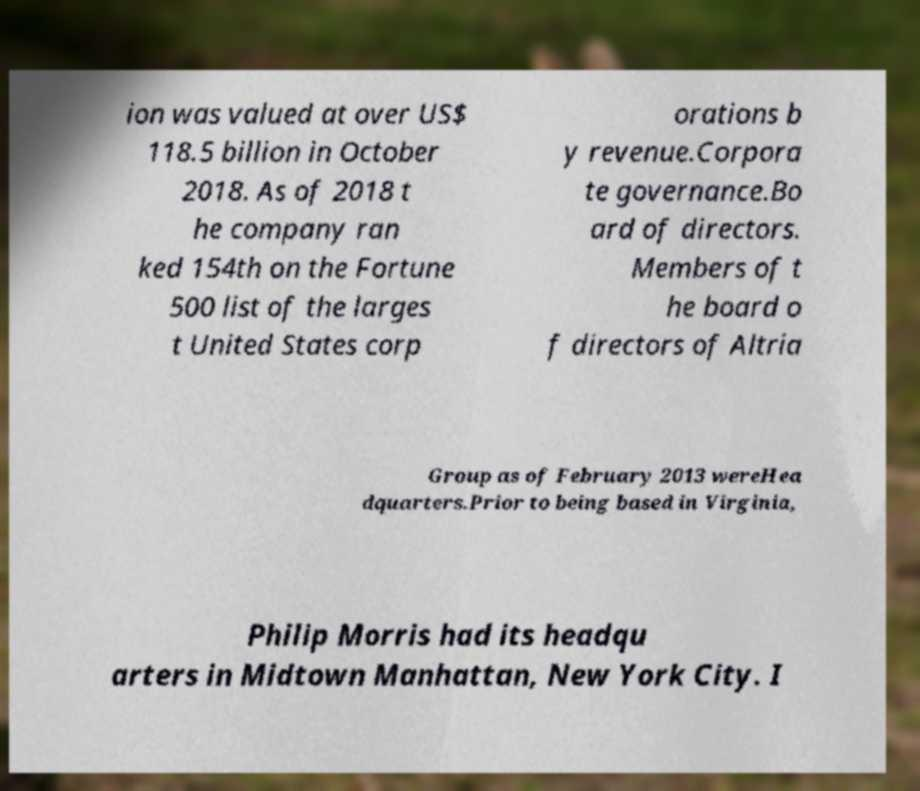Please identify and transcribe the text found in this image. ion was valued at over US$ 118.5 billion in October 2018. As of 2018 t he company ran ked 154th on the Fortune 500 list of the larges t United States corp orations b y revenue.Corpora te governance.Bo ard of directors. Members of t he board o f directors of Altria Group as of February 2013 wereHea dquarters.Prior to being based in Virginia, Philip Morris had its headqu arters in Midtown Manhattan, New York City. I 